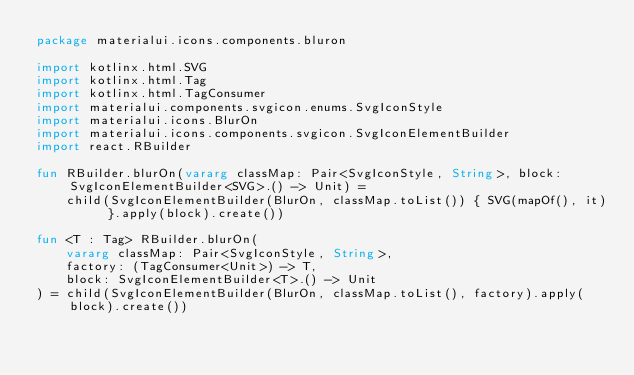<code> <loc_0><loc_0><loc_500><loc_500><_Kotlin_>package materialui.icons.components.bluron

import kotlinx.html.SVG
import kotlinx.html.Tag
import kotlinx.html.TagConsumer
import materialui.components.svgicon.enums.SvgIconStyle
import materialui.icons.BlurOn
import materialui.icons.components.svgicon.SvgIconElementBuilder
import react.RBuilder

fun RBuilder.blurOn(vararg classMap: Pair<SvgIconStyle, String>, block: SvgIconElementBuilder<SVG>.() -> Unit) =
    child(SvgIconElementBuilder(BlurOn, classMap.toList()) { SVG(mapOf(), it) }.apply(block).create())

fun <T : Tag> RBuilder.blurOn(
    vararg classMap: Pair<SvgIconStyle, String>,
    factory: (TagConsumer<Unit>) -> T,
    block: SvgIconElementBuilder<T>.() -> Unit
) = child(SvgIconElementBuilder(BlurOn, classMap.toList(), factory).apply(block).create())
</code> 